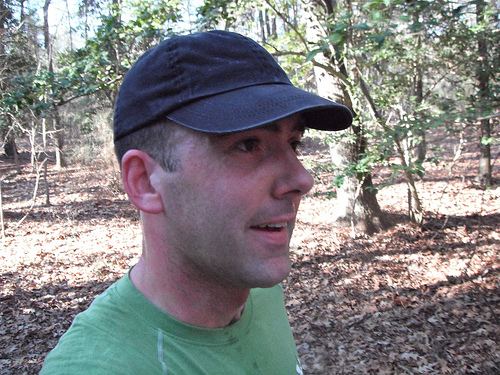<image>
Can you confirm if the hat is on the ground? No. The hat is not positioned on the ground. They may be near each other, but the hat is not supported by or resting on top of the ground. 